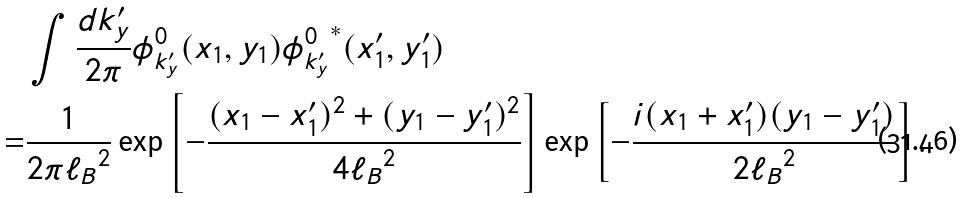<formula> <loc_0><loc_0><loc_500><loc_500>& \int \frac { d k _ { y } ^ { \prime } } { 2 \pi } \phi _ { k _ { y } ^ { \prime } } ^ { 0 } ( x _ { 1 } , y _ { 1 } ) { \phi _ { k _ { y } ^ { \prime } } ^ { 0 } } ^ { * } ( x _ { 1 } ^ { \prime } , y _ { 1 } ^ { \prime } ) \\ = & \frac { 1 } { 2 \pi { \ell _ { B } } ^ { 2 } } \exp \left [ - \frac { ( x _ { 1 } - x _ { 1 } ^ { \prime } ) ^ { 2 } + ( y _ { 1 } - y _ { 1 } ^ { \prime } ) ^ { 2 } } { 4 { \ell _ { B } } ^ { 2 } } \right ] \exp \left [ - \frac { i ( x _ { 1 } + x _ { 1 } ^ { \prime } ) ( y _ { 1 } - y _ { 1 } ^ { \prime } ) } { 2 { \ell _ { B } } ^ { 2 } } \right ] .</formula> 